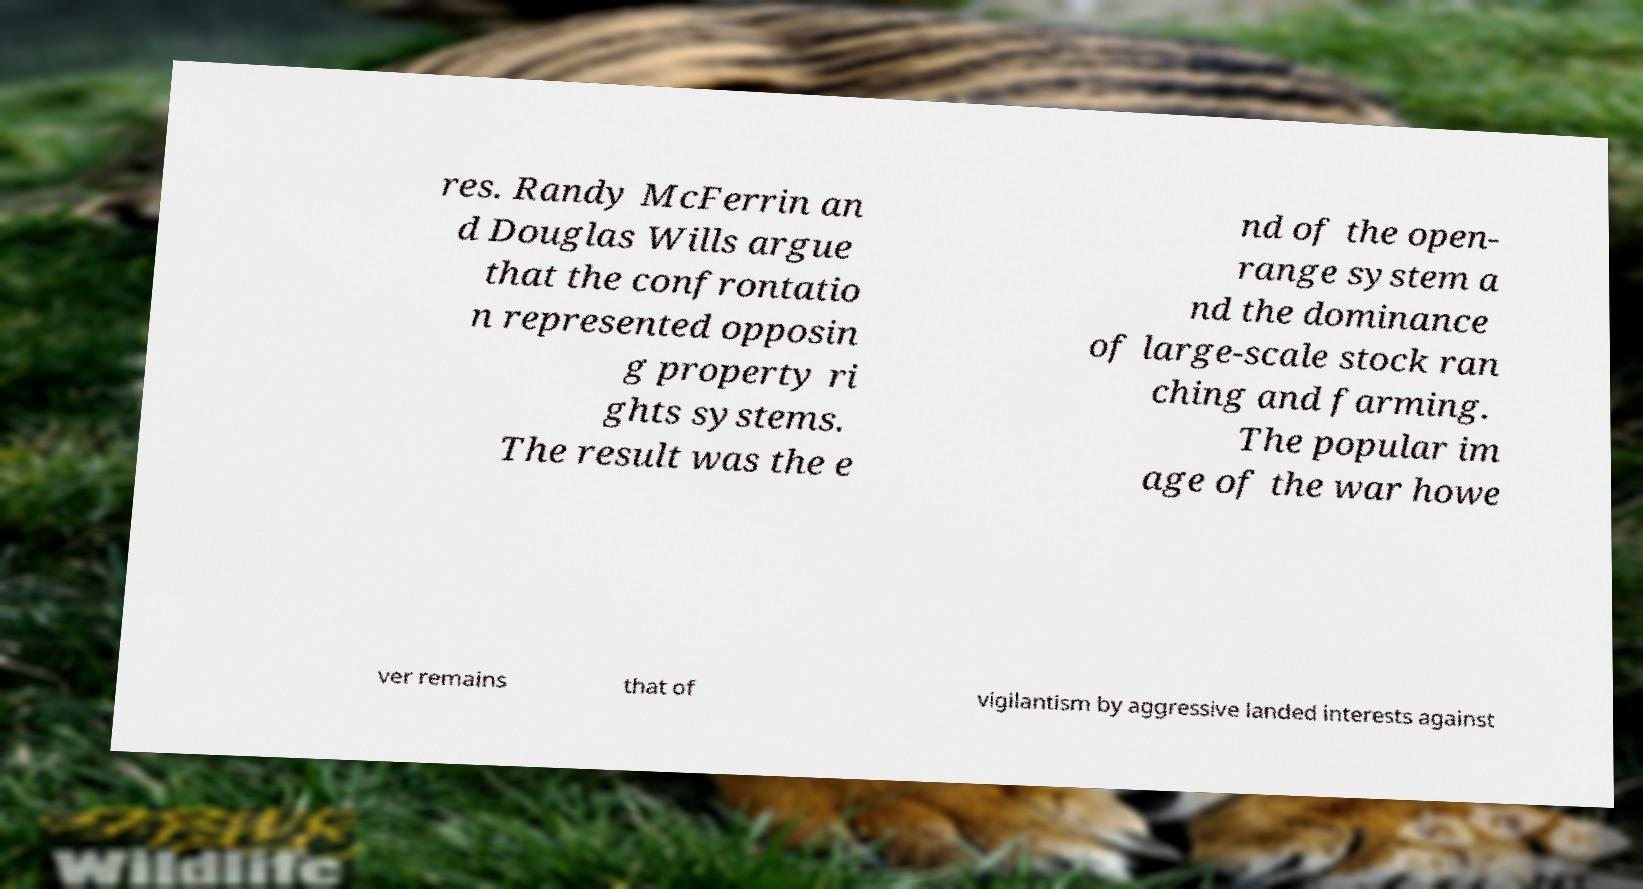Please identify and transcribe the text found in this image. res. Randy McFerrin an d Douglas Wills argue that the confrontatio n represented opposin g property ri ghts systems. The result was the e nd of the open- range system a nd the dominance of large-scale stock ran ching and farming. The popular im age of the war howe ver remains that of vigilantism by aggressive landed interests against 